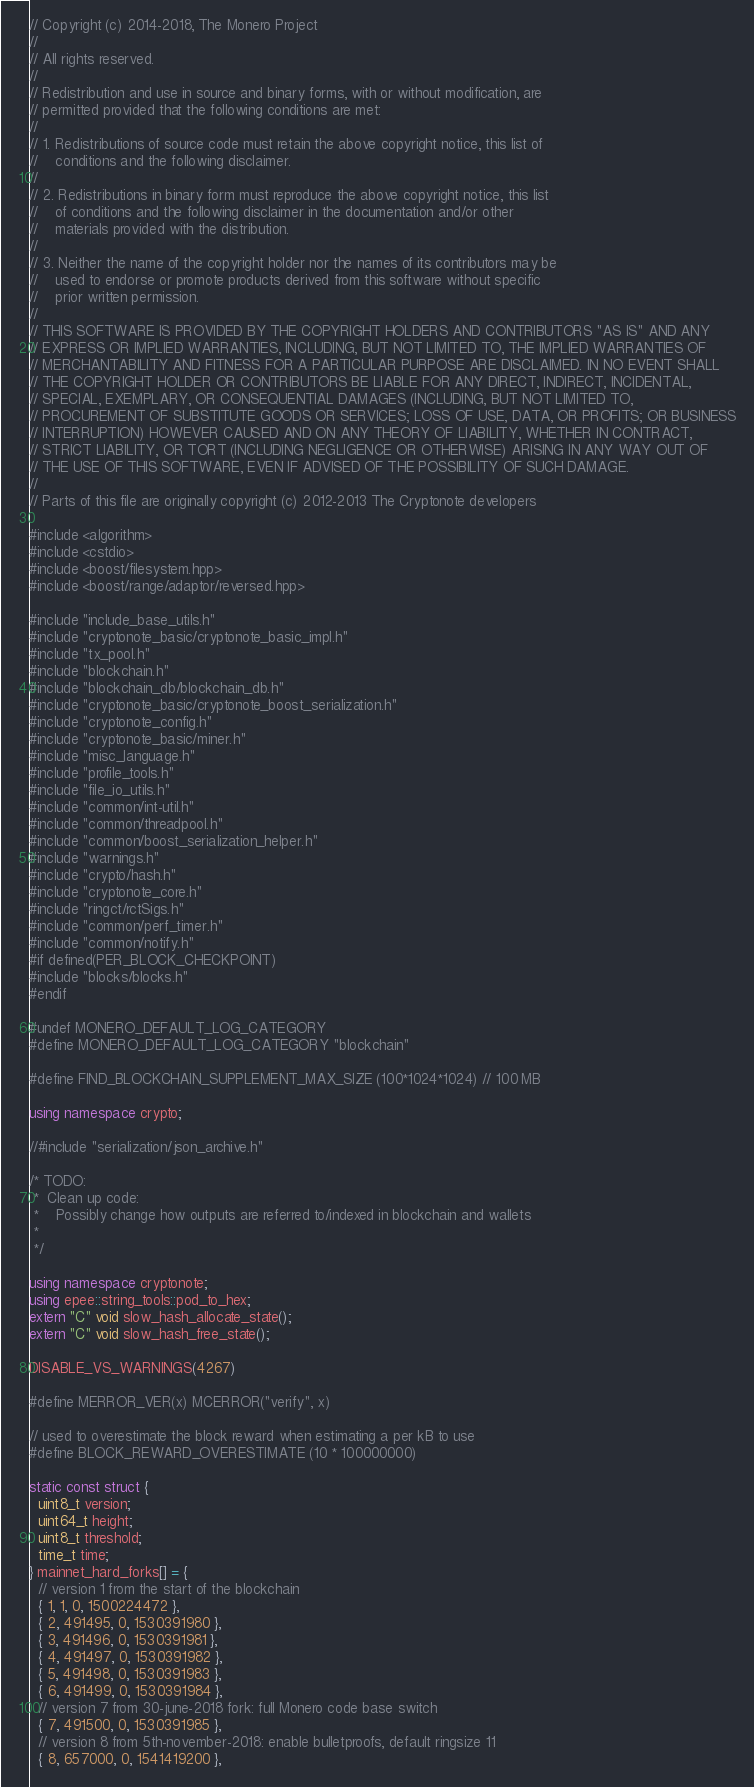<code> <loc_0><loc_0><loc_500><loc_500><_C++_>// Copyright (c) 2014-2018, The Monero Project
//
// All rights reserved.
//
// Redistribution and use in source and binary forms, with or without modification, are
// permitted provided that the following conditions are met:
//
// 1. Redistributions of source code must retain the above copyright notice, this list of
//    conditions and the following disclaimer.
//
// 2. Redistributions in binary form must reproduce the above copyright notice, this list
//    of conditions and the following disclaimer in the documentation and/or other
//    materials provided with the distribution.
//
// 3. Neither the name of the copyright holder nor the names of its contributors may be
//    used to endorse or promote products derived from this software without specific
//    prior written permission.
//
// THIS SOFTWARE IS PROVIDED BY THE COPYRIGHT HOLDERS AND CONTRIBUTORS "AS IS" AND ANY
// EXPRESS OR IMPLIED WARRANTIES, INCLUDING, BUT NOT LIMITED TO, THE IMPLIED WARRANTIES OF
// MERCHANTABILITY AND FITNESS FOR A PARTICULAR PURPOSE ARE DISCLAIMED. IN NO EVENT SHALL
// THE COPYRIGHT HOLDER OR CONTRIBUTORS BE LIABLE FOR ANY DIRECT, INDIRECT, INCIDENTAL,
// SPECIAL, EXEMPLARY, OR CONSEQUENTIAL DAMAGES (INCLUDING, BUT NOT LIMITED TO,
// PROCUREMENT OF SUBSTITUTE GOODS OR SERVICES; LOSS OF USE, DATA, OR PROFITS; OR BUSINESS
// INTERRUPTION) HOWEVER CAUSED AND ON ANY THEORY OF LIABILITY, WHETHER IN CONTRACT,
// STRICT LIABILITY, OR TORT (INCLUDING NEGLIGENCE OR OTHERWISE) ARISING IN ANY WAY OUT OF
// THE USE OF THIS SOFTWARE, EVEN IF ADVISED OF THE POSSIBILITY OF SUCH DAMAGE.
//
// Parts of this file are originally copyright (c) 2012-2013 The Cryptonote developers

#include <algorithm>
#include <cstdio>
#include <boost/filesystem.hpp>
#include <boost/range/adaptor/reversed.hpp>

#include "include_base_utils.h"
#include "cryptonote_basic/cryptonote_basic_impl.h"
#include "tx_pool.h"
#include "blockchain.h"
#include "blockchain_db/blockchain_db.h"
#include "cryptonote_basic/cryptonote_boost_serialization.h"
#include "cryptonote_config.h"
#include "cryptonote_basic/miner.h"
#include "misc_language.h"
#include "profile_tools.h"
#include "file_io_utils.h"
#include "common/int-util.h"
#include "common/threadpool.h"
#include "common/boost_serialization_helper.h"
#include "warnings.h"
#include "crypto/hash.h"
#include "cryptonote_core.h"
#include "ringct/rctSigs.h"
#include "common/perf_timer.h"
#include "common/notify.h"
#if defined(PER_BLOCK_CHECKPOINT)
#include "blocks/blocks.h"
#endif

#undef MONERO_DEFAULT_LOG_CATEGORY
#define MONERO_DEFAULT_LOG_CATEGORY "blockchain"

#define FIND_BLOCKCHAIN_SUPPLEMENT_MAX_SIZE (100*1024*1024) // 100 MB

using namespace crypto;

//#include "serialization/json_archive.h"

/* TODO:
 *  Clean up code:
 *    Possibly change how outputs are referred to/indexed in blockchain and wallets
 *
 */

using namespace cryptonote;
using epee::string_tools::pod_to_hex;
extern "C" void slow_hash_allocate_state();
extern "C" void slow_hash_free_state();

DISABLE_VS_WARNINGS(4267)

#define MERROR_VER(x) MCERROR("verify", x)

// used to overestimate the block reward when estimating a per kB to use
#define BLOCK_REWARD_OVERESTIMATE (10 * 100000000)

static const struct {
  uint8_t version;
  uint64_t height;
  uint8_t threshold;
  time_t time;
} mainnet_hard_forks[] = {
  // version 1 from the start of the blockchain
  { 1, 1, 0, 1500224472 },
  { 2, 491495, 0, 1530391980 },
  { 3, 491496, 0, 1530391981 },
  { 4, 491497, 0, 1530391982 },
  { 5, 491498, 0, 1530391983 },
  { 6, 491499, 0, 1530391984 },
  // version 7 from 30-june-2018 fork: full Monero code base switch
  { 7, 491500, 0, 1530391985 },
  // version 8 from 5th-november-2018: enable bulletproofs, default ringsize 11
  { 8, 657000, 0, 1541419200 },</code> 